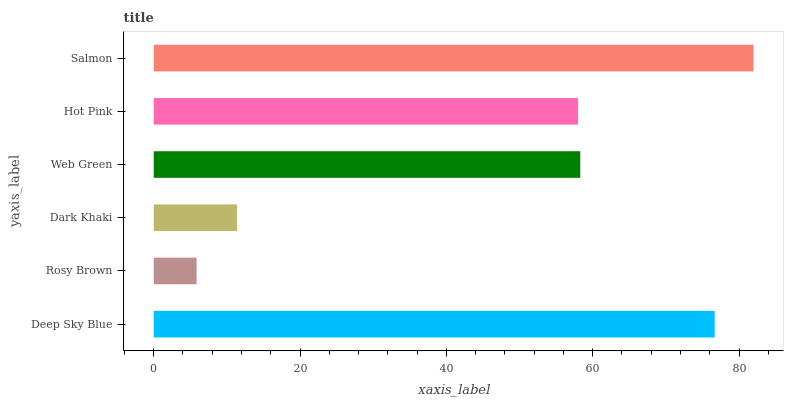Is Rosy Brown the minimum?
Answer yes or no. Yes. Is Salmon the maximum?
Answer yes or no. Yes. Is Dark Khaki the minimum?
Answer yes or no. No. Is Dark Khaki the maximum?
Answer yes or no. No. Is Dark Khaki greater than Rosy Brown?
Answer yes or no. Yes. Is Rosy Brown less than Dark Khaki?
Answer yes or no. Yes. Is Rosy Brown greater than Dark Khaki?
Answer yes or no. No. Is Dark Khaki less than Rosy Brown?
Answer yes or no. No. Is Web Green the high median?
Answer yes or no. Yes. Is Hot Pink the low median?
Answer yes or no. Yes. Is Hot Pink the high median?
Answer yes or no. No. Is Dark Khaki the low median?
Answer yes or no. No. 